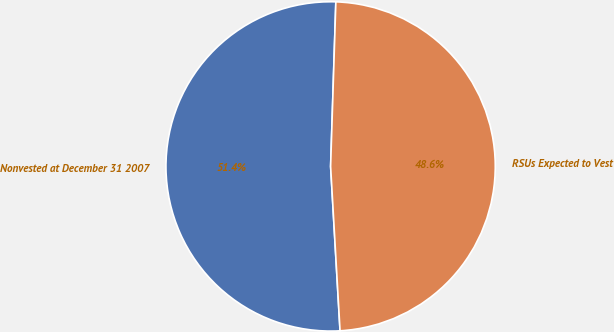Convert chart. <chart><loc_0><loc_0><loc_500><loc_500><pie_chart><fcel>Nonvested at December 31 2007<fcel>RSUs Expected to Vest<nl><fcel>51.42%<fcel>48.58%<nl></chart> 